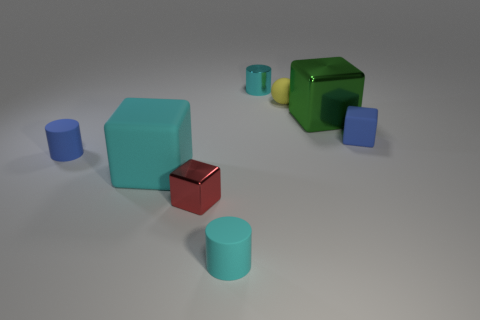Subtract all small rubber cylinders. How many cylinders are left? 1 Subtract all gray spheres. How many cyan cylinders are left? 2 Subtract 1 cylinders. How many cylinders are left? 2 Subtract all green blocks. How many blocks are left? 3 Add 2 brown rubber objects. How many objects exist? 10 Subtract all red cylinders. Subtract all red balls. How many cylinders are left? 3 Subtract all blue things. Subtract all green blocks. How many objects are left? 5 Add 3 small yellow rubber objects. How many small yellow rubber objects are left? 4 Add 6 tiny spheres. How many tiny spheres exist? 7 Subtract 1 red blocks. How many objects are left? 7 